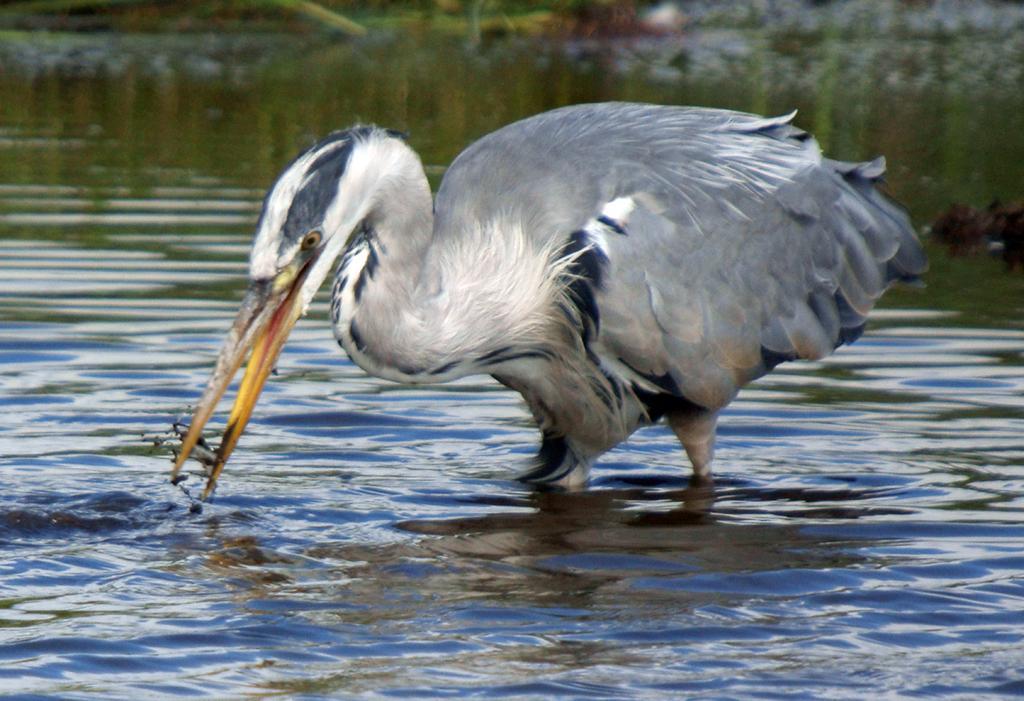Please provide a concise description of this image. In the center of the picture there is a bird trying to catch fish. The bird is in a water body. The background is blurred. 